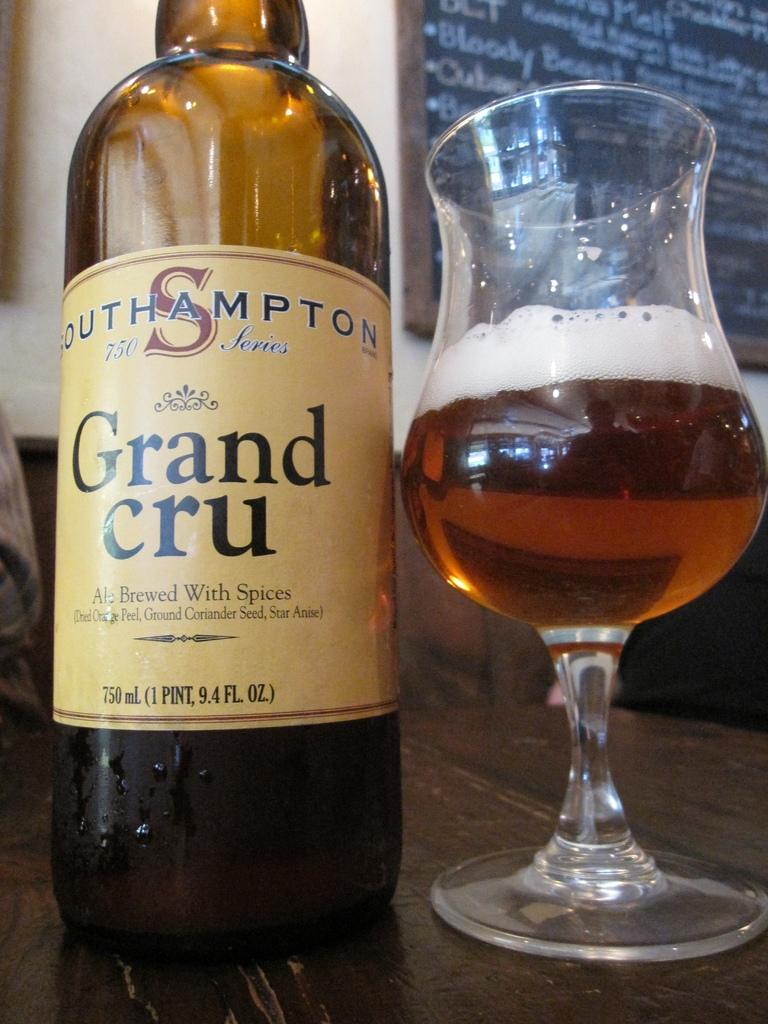Provide a one-sentence caption for the provided image. A 750 milliliter bottle of Grand Cru and a glass of beer rest on a wooden surface. 